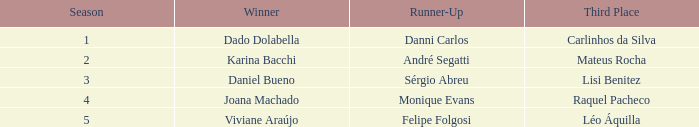Could you help me parse every detail presented in this table? {'header': ['Season', 'Winner', 'Runner-Up', 'Third Place'], 'rows': [['1', 'Dado Dolabella', 'Danni Carlos', 'Carlinhos da Silva'], ['2', 'Karina Bacchi', 'André Segatti', 'Mateus Rocha'], ['3', 'Daniel Bueno', 'Sérgio Abreu', 'Lisi Benitez'], ['4', 'Joana Machado', 'Monique Evans', 'Raquel Pacheco'], ['5', 'Viviane Araújo', 'Felipe Folgosi', 'Léo Áquilla']]} Who was the winner when Mateus Rocha finished in 3rd place?  Karina Bacchi. 